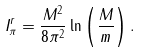<formula> <loc_0><loc_0><loc_500><loc_500>I _ { \pi } ^ { r } = \frac { M ^ { 2 } } { 8 \pi ^ { 2 } } \ln \left ( \frac { M } { m } \right ) .</formula> 